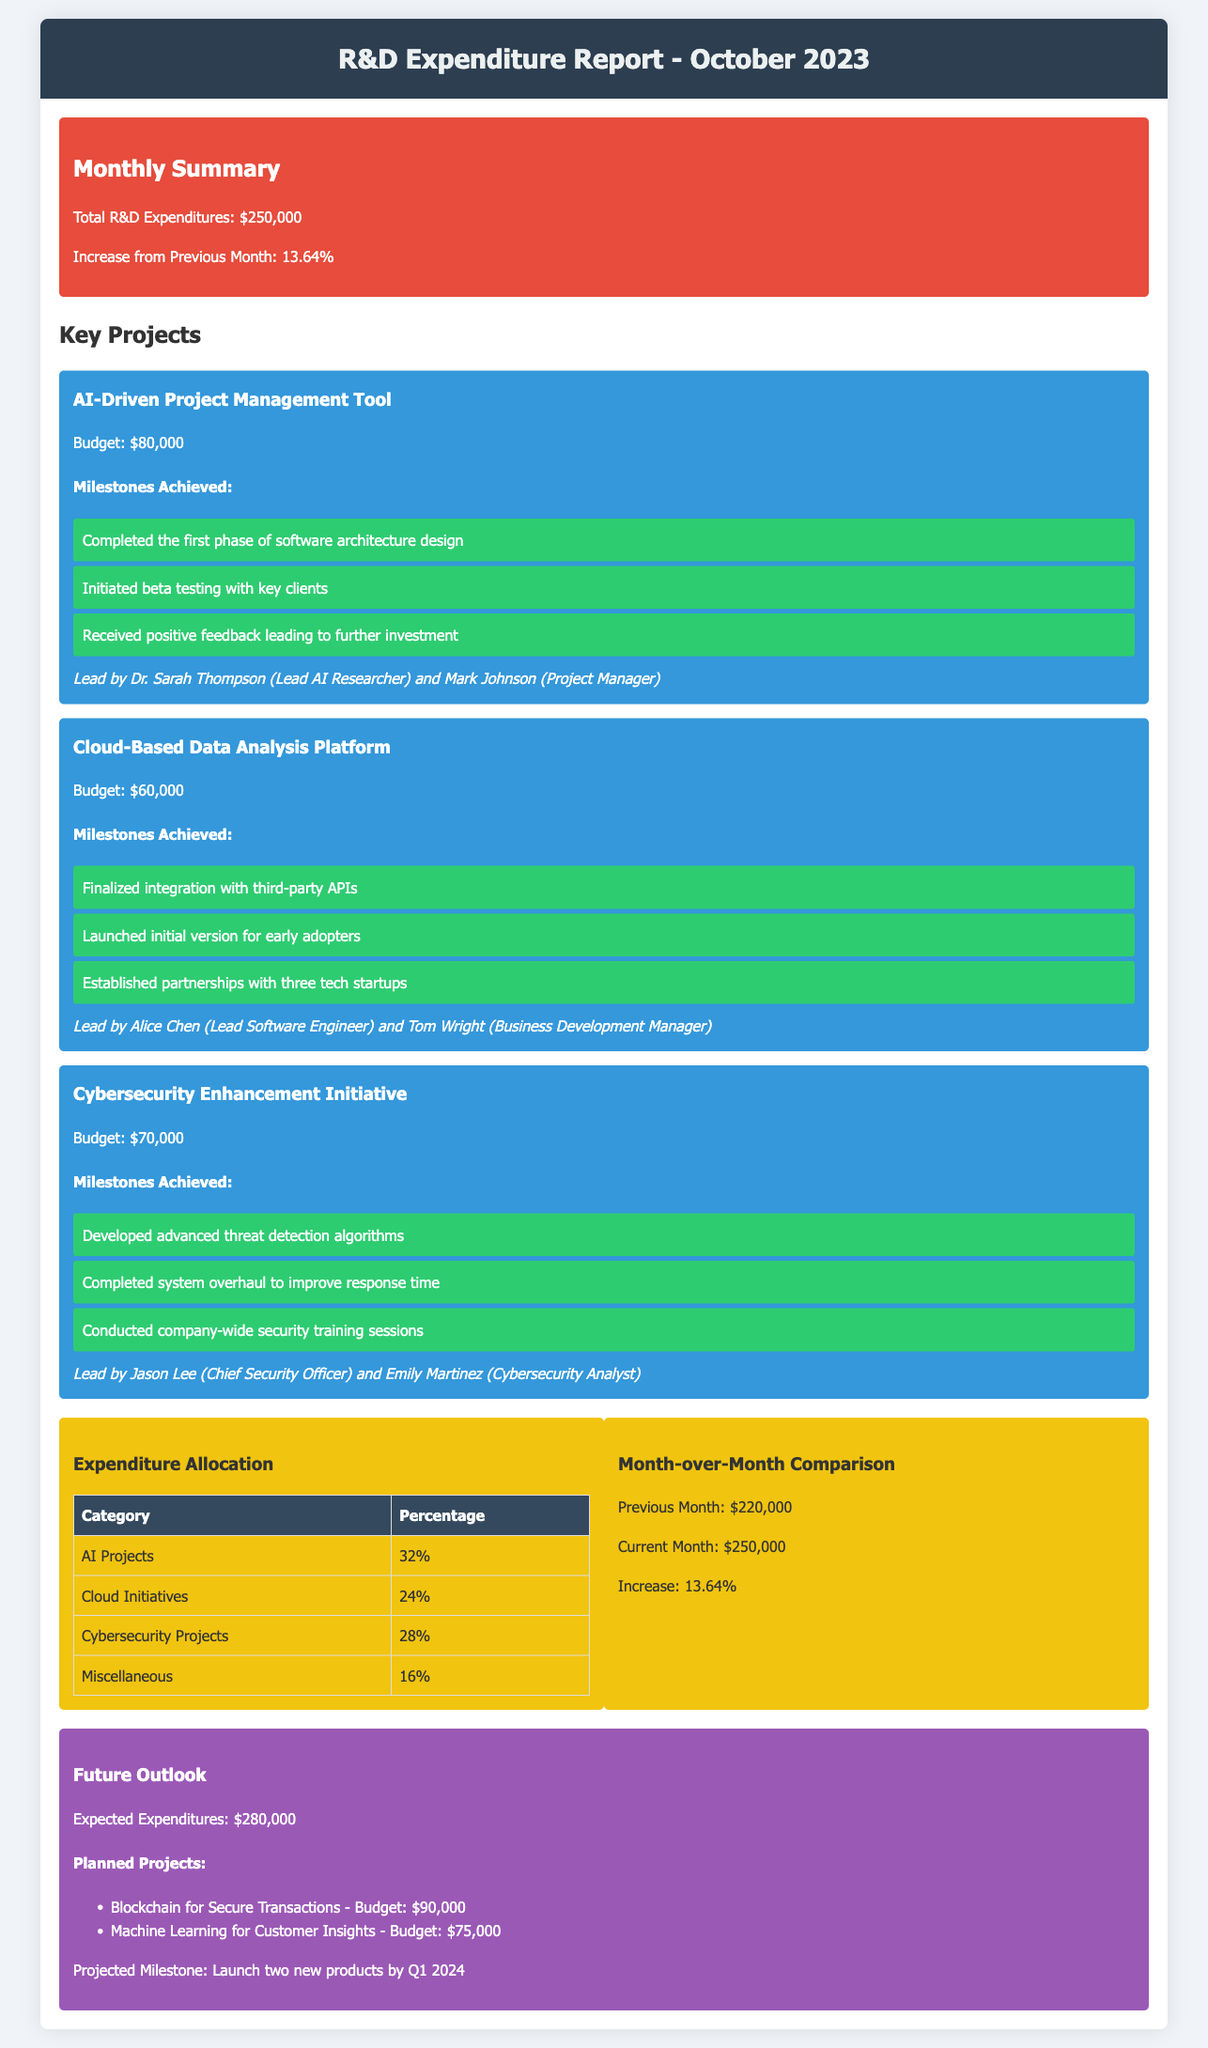what was the total R&D expenditure for October 2023? The total R&D expenditure is explicitly stated in the document as $250,000.
Answer: $250,000 what percentage increase was observed from the previous month? The increase from the previous month is mentioned as 13.64%.
Answer: 13.64% which project had the highest budget? The budgets for each project are listed, and the AI-Driven Project Management Tool has the highest budget of $80,000.
Answer: $80,000 who is the team lead for the Cybersecurity Enhancement Initiative? The document provides the name of the team lead for this initiative as Jason Lee (Chief Security Officer) and Emily Martinez (Cybersecurity Analyst).
Answer: Jason Lee and Emily Martinez how much is the expected expenditure for the next month? The future outlook section indicates the expected expenditures as $280,000.
Answer: $280,000 what are the two planned projects listed for future expenditures? The planned projects for future expenditures are mentioned as Blockchain for Secure Transactions and Machine Learning for Customer Insights.
Answer: Blockchain for Secure Transactions and Machine Learning for Customer Insights what percentage of the budget was allocated to Cybersecurity Projects? The expenditure allocation provides the percentage allocated to Cybersecurity Projects as 28%.
Answer: 28% how many tech startups were partnered with in the Cloud-Based Data Analysis Platform project? The document states there are three tech startups partnered with this project.
Answer: three what milestone was achieved in the AI-Driven Project Management Tool project? The document lists that one of the milestones achieved was "Completed the first phase of software architecture design."
Answer: Completed the first phase of software architecture design 